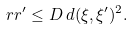<formula> <loc_0><loc_0><loc_500><loc_500>r r ^ { \prime } \leq D \, d ( \xi , \xi ^ { \prime } ) ^ { 2 } .</formula> 